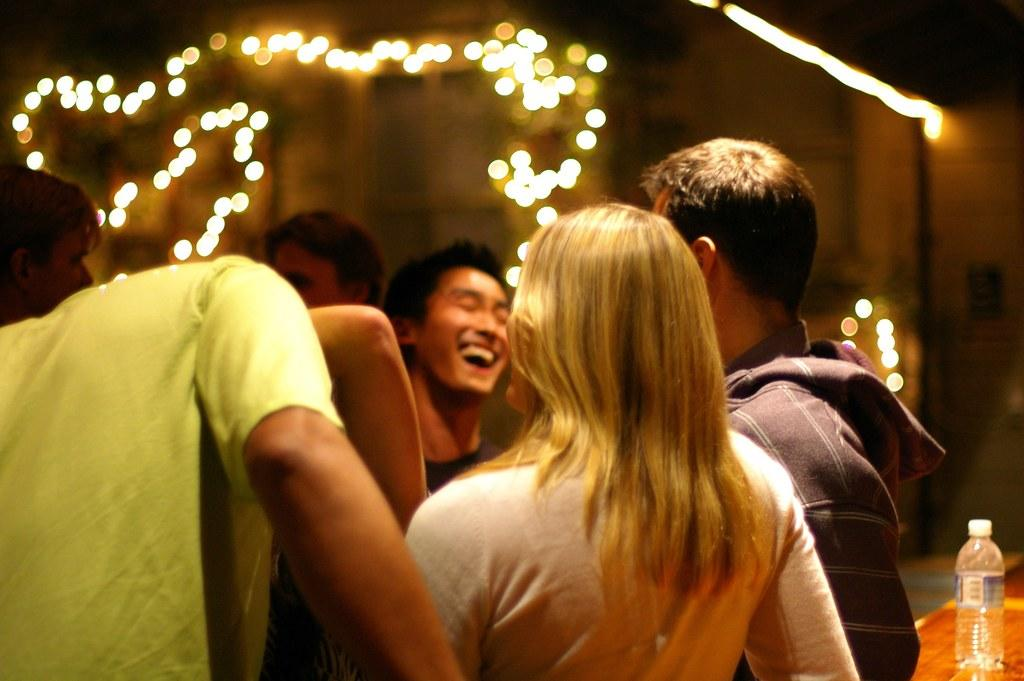How many people are in the image? There is a group of people in the image. What are the people in the image doing? The people are standing and chatting. What can be seen in the background of the image? There are lights and a table in the background of the image. What is on the table in the image? There is a bottle on the table. What type of birds can be seen flying around the people in the image? There are no birds visible in the image; it only shows a group of people standing and chatting. What kind of board is being used by the people in the image? There is no board present in the image; the people are simply standing and chatting. 